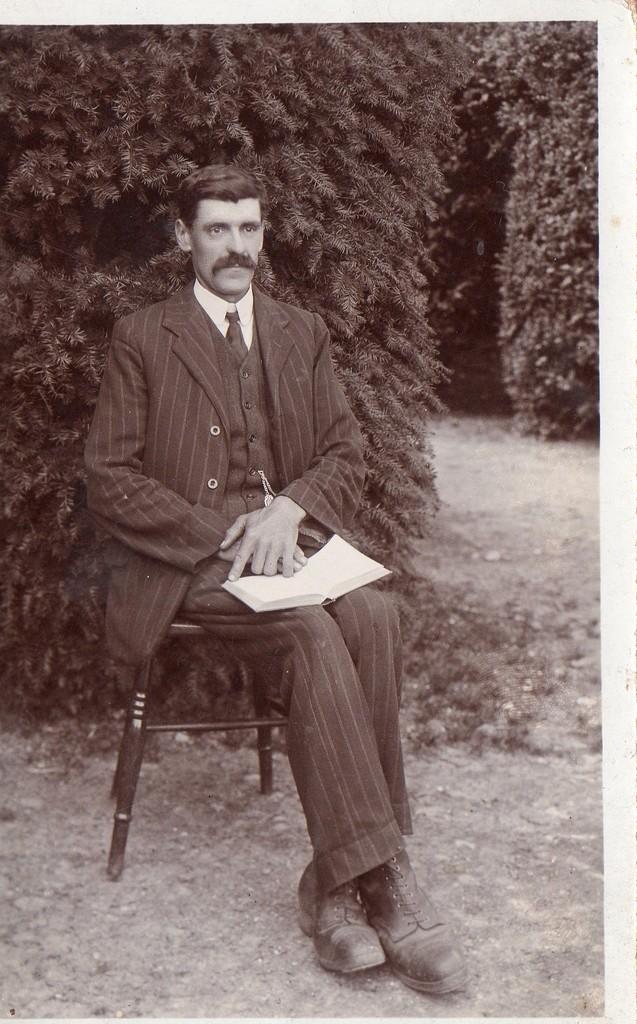Describe this image in one or two sentences. In this image I can see the person sitting and holding the book. In the background I can see few trees and the image is in black and white. 